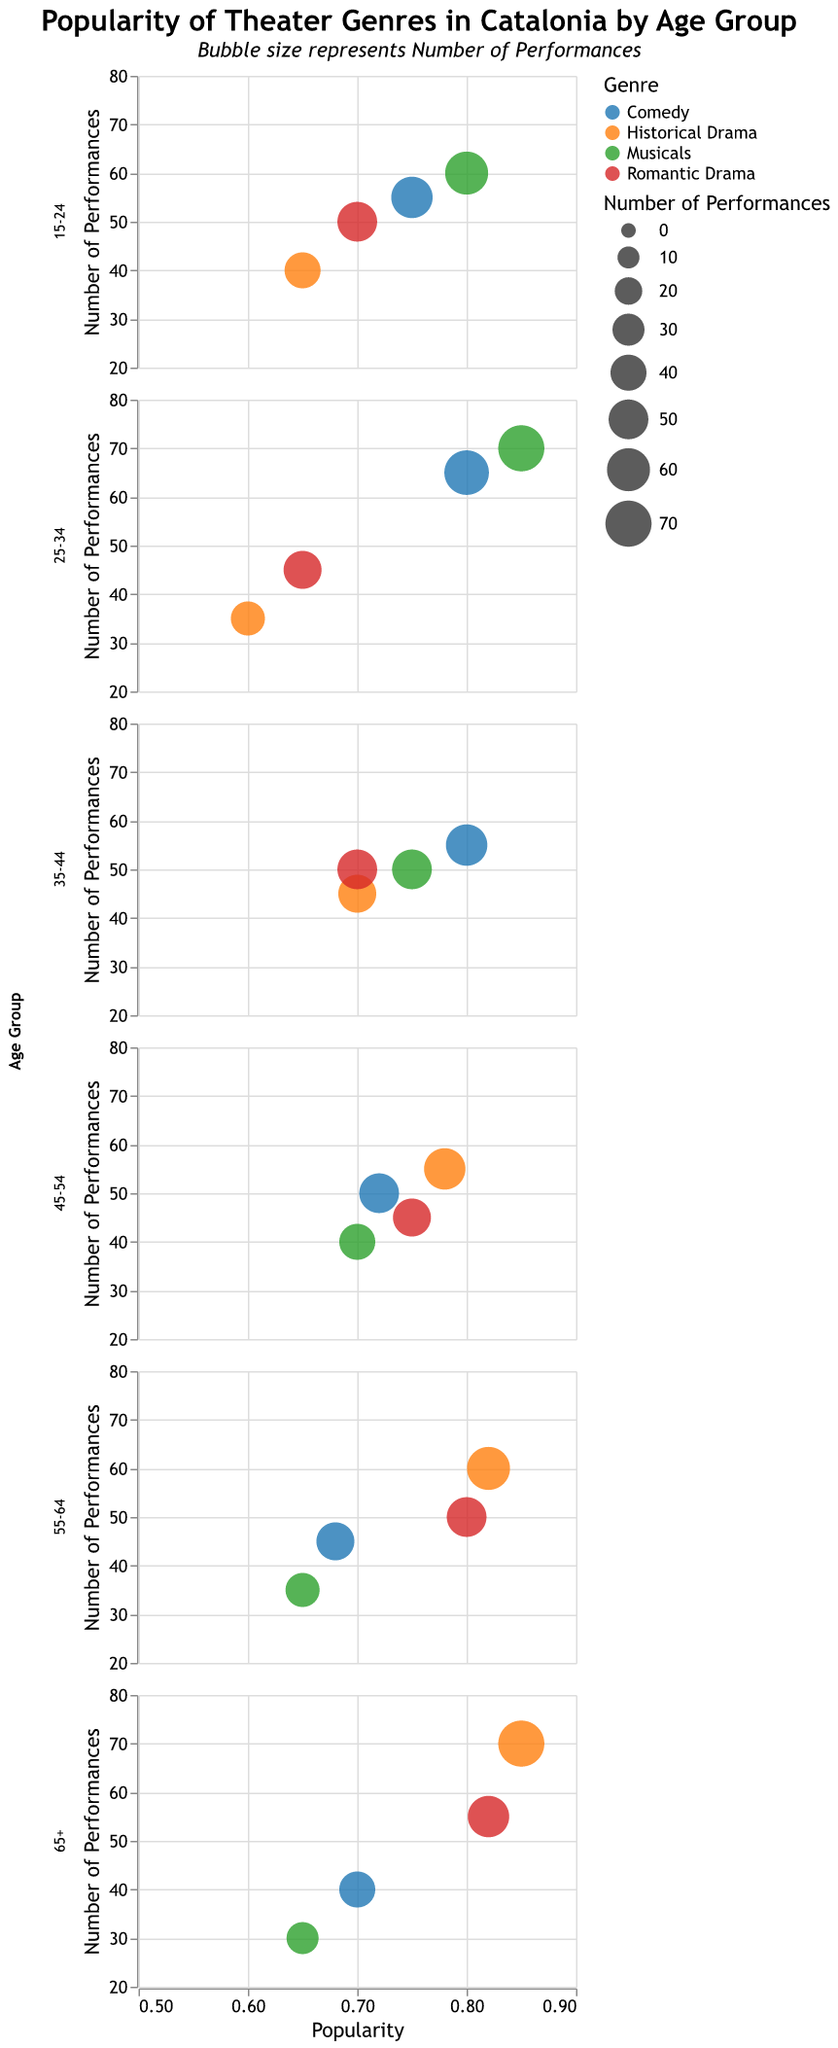What is the title of the chart? The title is located at the top of the chart and provides a summary of what the chart represents.
Answer: Popularity of Theater Genres in Catalonia by Age Group Which age group shows the highest popularity for Musicals? To find this, look at the bubbles for Musicals across all age groups and identify the one with the highest value on the x-axis (popularity).
Answer: 25-34 How many performances of Historical Drama are there for the 65+ age group? Look for the bubble representing Historical Drama in the subplot for the 65+ age group. The number of performances is shown by the size of the bubble and provided in the tooltip.
Answer: 70 Which genre has the lowest popularity in the age group 55-64? Examine the x-axis (popularity) in the subplot for the 55-64 age group and find the genre with the lowest value.
Answer: Musicals Compare the popularity of Comedy in the age groups 15-24 and 45-54. Which is higher? Check the values on the x-axis for Comedy in both the 15-24 and 45-54 age groups, and compare which is higher.
Answer: 15-24 What is the total number of performances for Romantic Drama across all age groups? Sum the number of performances for Romantic Drama from each age group: (50 + 45 + 50 + 45 + 50 + 55).
Answer: 295 Which age group has the greatest number of performances for Comedy? Identify the largest bubble representing Comedy within each age group subplot.
Answer: 25-34 What is the difference in popularity for Historical Drama between the age groups 15-24 and 65+? Subtract the popularity value of Historical Drama in age group 15-24 from the popularity value in age group 65+ (0.85 - 0.65).
Answer: 0.20 Is the popularity of Romantic Drama higher or lower for the age group 55-64 compared to the age group 25-34? Check the x-axis values for Romantic Drama in both age groups and compare them.
Answer: Higher Which genre has the most variation in the number of performances across different age groups? Observe the size of bubbles for each genre across all age groups to identify the one with the most significant difference in bubble sizes.
Answer: Musicals 